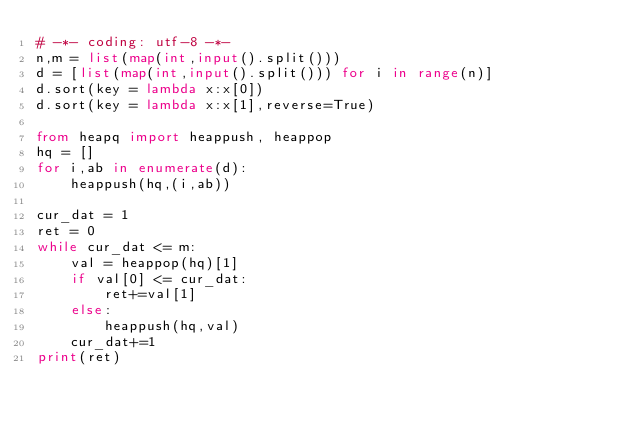Convert code to text. <code><loc_0><loc_0><loc_500><loc_500><_Python_># -*- coding: utf-8 -*-
n,m = list(map(int,input().split()))
d = [list(map(int,input().split())) for i in range(n)]
d.sort(key = lambda x:x[0])
d.sort(key = lambda x:x[1],reverse=True)

from heapq import heappush, heappop
hq = []
for i,ab in enumerate(d):
    heappush(hq,(i,ab))

cur_dat = 1
ret = 0
while cur_dat <= m:
    val = heappop(hq)[1]
    if val[0] <= cur_dat:
        ret+=val[1]
    else:
        heappush(hq,val)
    cur_dat+=1
print(ret)
</code> 